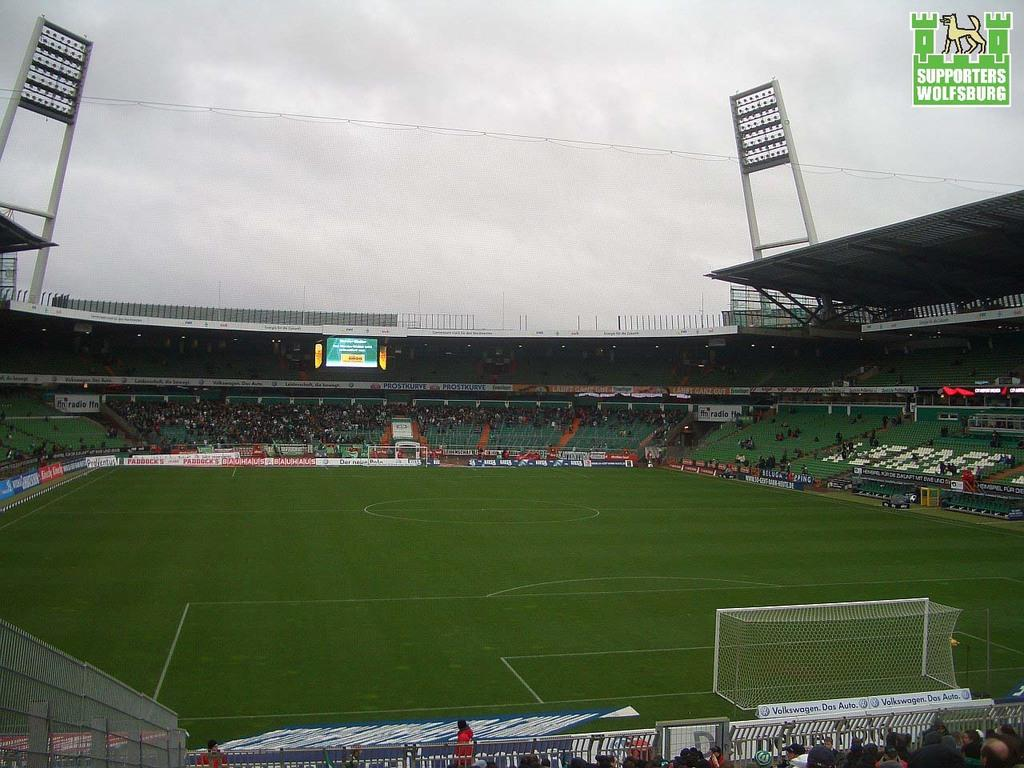What is the main structure in the image? There is a stadium in the image. What is the ground of the stadium like? The stadium has a greenery ground. Are there any people present in the image? Yes, there are people around the ground. What can be seen in the background of the image? There are two flood lights in the background. What type of stamp can be seen on the flood lights in the image? There are no stamps visible on the flood lights in the image. What kind of breakfast is being served to the people around the ground in the image? There is no indication of any food or breakfast being served in the image. 